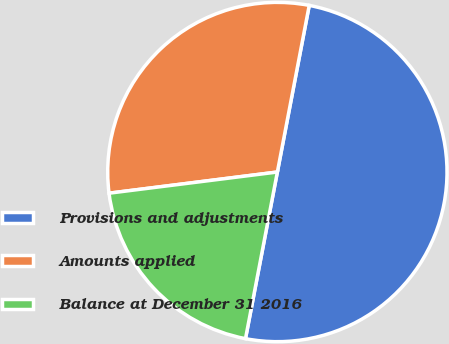Convert chart. <chart><loc_0><loc_0><loc_500><loc_500><pie_chart><fcel>Provisions and adjustments<fcel>Amounts applied<fcel>Balance at December 31 2016<nl><fcel>50.0%<fcel>30.0%<fcel>20.0%<nl></chart> 